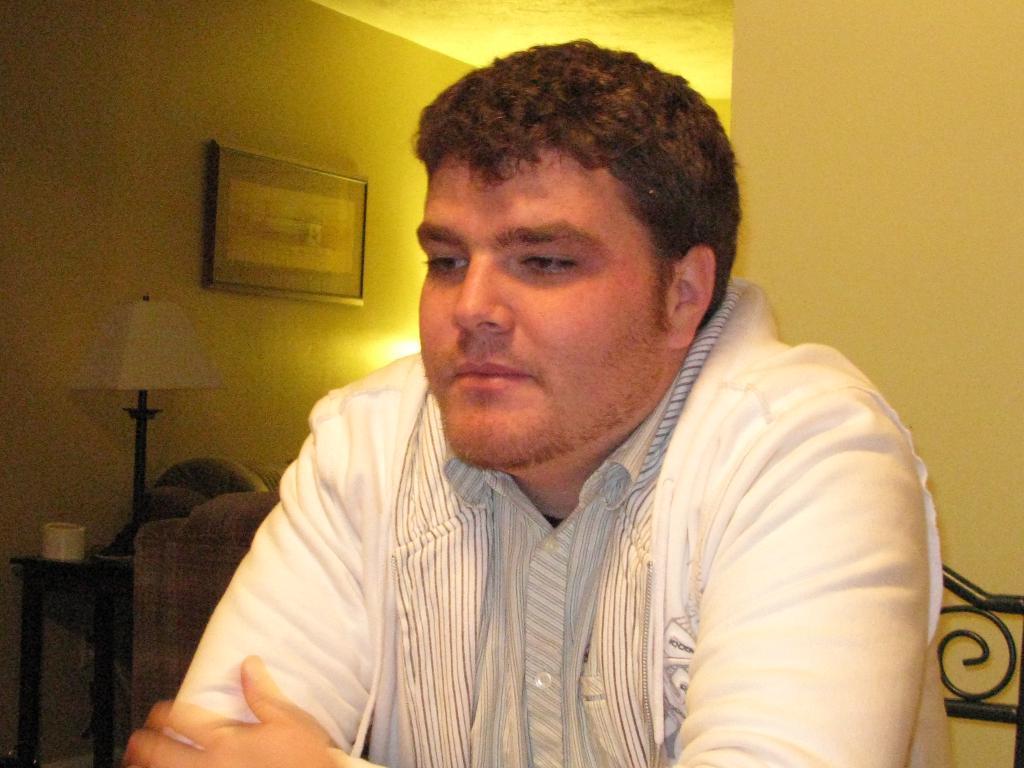Can you describe this image briefly? In this picture I can observe a man in the middle of the picture. On the left side I can observe a lamp placed on the stool. In the background I can observe a photo frame on the wall. 